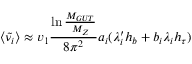<formula> <loc_0><loc_0><loc_500><loc_500>\langle \tilde { \nu _ { i } } \rangle \approx v _ { 1 } { \frac { \ln { \frac { M _ { G U T } } { M _ { Z } } } } { 8 \pi ^ { 2 } } } a _ { i } ( \lambda _ { i } ^ { \prime } h _ { b } + b _ { i } \lambda _ { i } h _ { \tau } )</formula> 